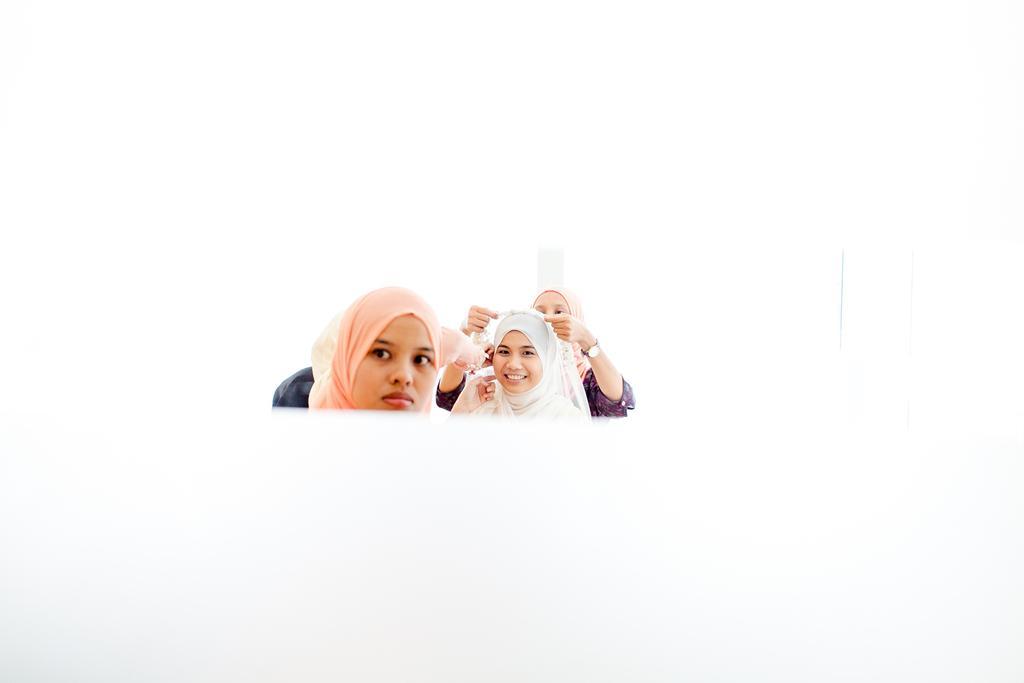Could you give a brief overview of what you see in this image? In the image there are three women and the background of the woman is in white color. 